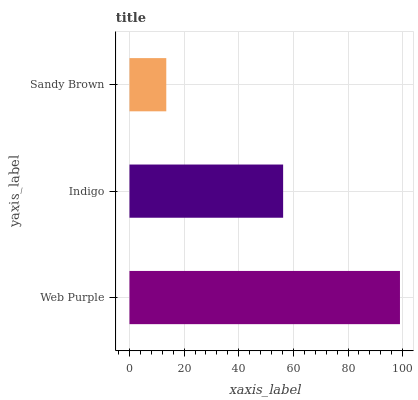Is Sandy Brown the minimum?
Answer yes or no. Yes. Is Web Purple the maximum?
Answer yes or no. Yes. Is Indigo the minimum?
Answer yes or no. No. Is Indigo the maximum?
Answer yes or no. No. Is Web Purple greater than Indigo?
Answer yes or no. Yes. Is Indigo less than Web Purple?
Answer yes or no. Yes. Is Indigo greater than Web Purple?
Answer yes or no. No. Is Web Purple less than Indigo?
Answer yes or no. No. Is Indigo the high median?
Answer yes or no. Yes. Is Indigo the low median?
Answer yes or no. Yes. Is Sandy Brown the high median?
Answer yes or no. No. Is Sandy Brown the low median?
Answer yes or no. No. 